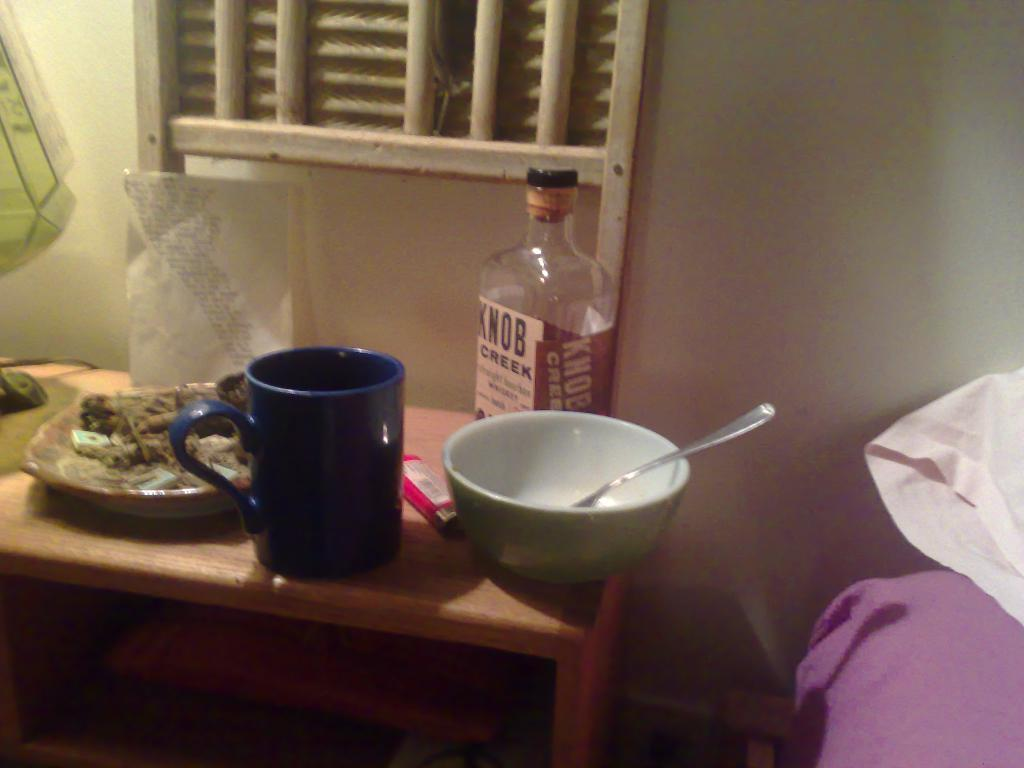<image>
Offer a succinct explanation of the picture presented. A bottle of Knob Creek Bourbon sitting on a table with other stuff. 